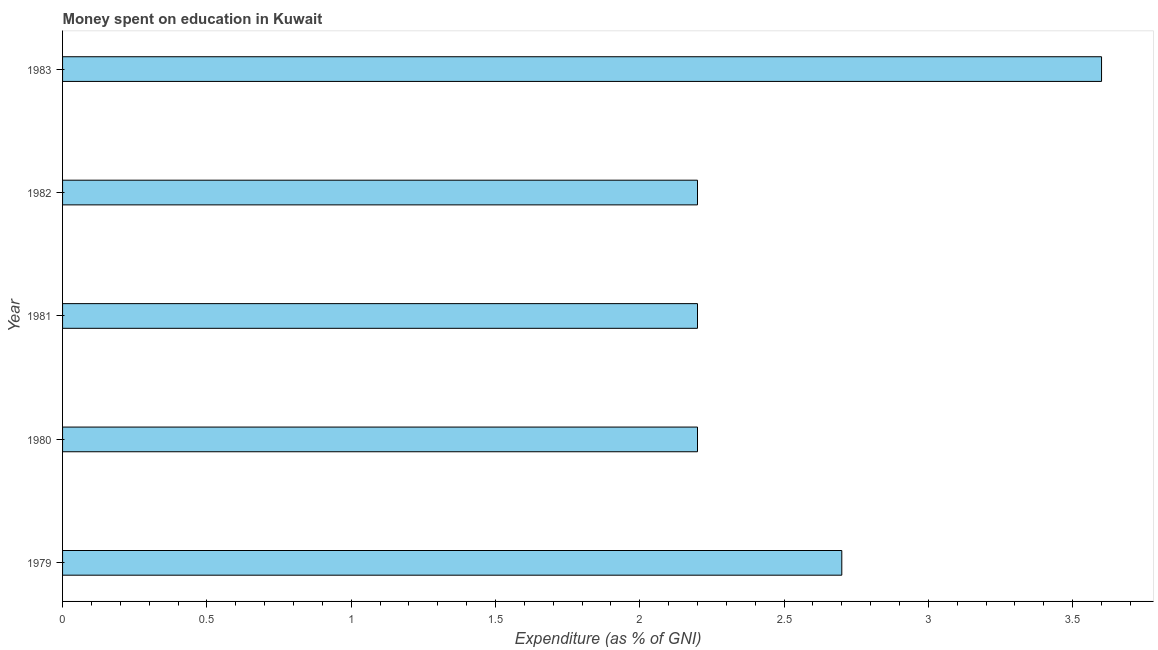Does the graph contain grids?
Your answer should be compact. No. What is the title of the graph?
Provide a succinct answer. Money spent on education in Kuwait. What is the label or title of the X-axis?
Your answer should be compact. Expenditure (as % of GNI). What is the label or title of the Y-axis?
Give a very brief answer. Year. What is the expenditure on education in 1982?
Make the answer very short. 2.2. Across all years, what is the maximum expenditure on education?
Provide a succinct answer. 3.6. Across all years, what is the minimum expenditure on education?
Your response must be concise. 2.2. What is the difference between the expenditure on education in 1980 and 1981?
Ensure brevity in your answer.  0. What is the average expenditure on education per year?
Provide a short and direct response. 2.58. Do a majority of the years between 1983 and 1981 (inclusive) have expenditure on education greater than 3.6 %?
Offer a very short reply. Yes. What is the ratio of the expenditure on education in 1981 to that in 1983?
Ensure brevity in your answer.  0.61. Is the difference between the expenditure on education in 1980 and 1981 greater than the difference between any two years?
Your response must be concise. No. Is the sum of the expenditure on education in 1980 and 1982 greater than the maximum expenditure on education across all years?
Your answer should be compact. Yes. How many years are there in the graph?
Ensure brevity in your answer.  5. What is the Expenditure (as % of GNI) of 1979?
Your answer should be compact. 2.7. What is the Expenditure (as % of GNI) in 1982?
Ensure brevity in your answer.  2.2. What is the difference between the Expenditure (as % of GNI) in 1979 and 1981?
Make the answer very short. 0.5. What is the difference between the Expenditure (as % of GNI) in 1979 and 1983?
Give a very brief answer. -0.9. What is the difference between the Expenditure (as % of GNI) in 1980 and 1981?
Your response must be concise. 0. What is the difference between the Expenditure (as % of GNI) in 1981 and 1982?
Keep it short and to the point. 0. What is the difference between the Expenditure (as % of GNI) in 1981 and 1983?
Offer a very short reply. -1.4. What is the difference between the Expenditure (as % of GNI) in 1982 and 1983?
Provide a succinct answer. -1.4. What is the ratio of the Expenditure (as % of GNI) in 1979 to that in 1980?
Offer a terse response. 1.23. What is the ratio of the Expenditure (as % of GNI) in 1979 to that in 1981?
Offer a terse response. 1.23. What is the ratio of the Expenditure (as % of GNI) in 1979 to that in 1982?
Provide a short and direct response. 1.23. What is the ratio of the Expenditure (as % of GNI) in 1979 to that in 1983?
Make the answer very short. 0.75. What is the ratio of the Expenditure (as % of GNI) in 1980 to that in 1983?
Ensure brevity in your answer.  0.61. What is the ratio of the Expenditure (as % of GNI) in 1981 to that in 1982?
Give a very brief answer. 1. What is the ratio of the Expenditure (as % of GNI) in 1981 to that in 1983?
Ensure brevity in your answer.  0.61. What is the ratio of the Expenditure (as % of GNI) in 1982 to that in 1983?
Keep it short and to the point. 0.61. 